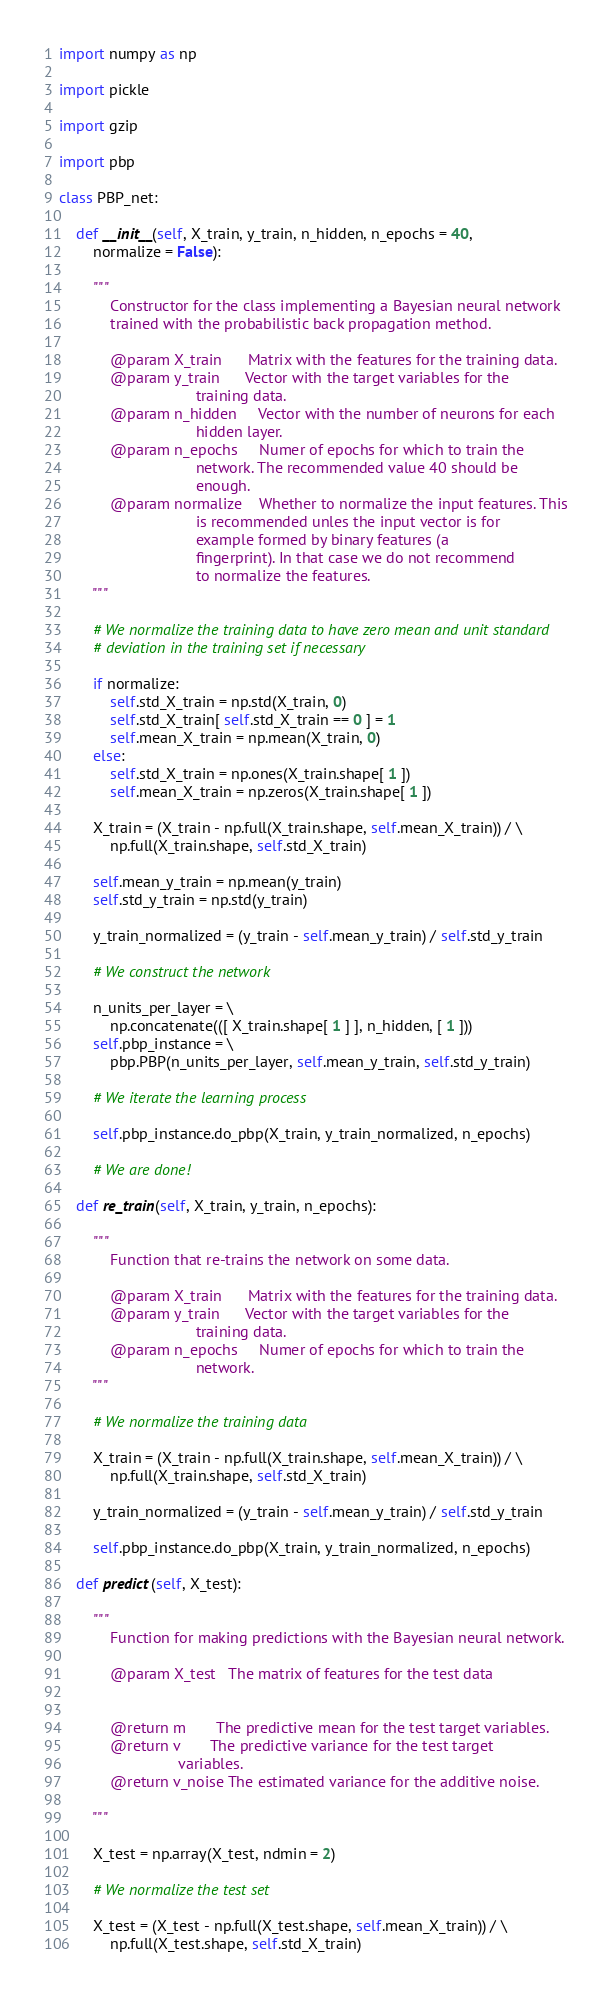<code> <loc_0><loc_0><loc_500><loc_500><_Python_>
import numpy as np

import pickle

import gzip

import pbp

class PBP_net:

    def __init__(self, X_train, y_train, n_hidden, n_epochs = 40,
        normalize = False):

        """
            Constructor for the class implementing a Bayesian neural network
            trained with the probabilistic back propagation method.

            @param X_train      Matrix with the features for the training data.
            @param y_train      Vector with the target variables for the
                                training data.
            @param n_hidden     Vector with the number of neurons for each
                                hidden layer.
            @param n_epochs     Numer of epochs for which to train the
                                network. The recommended value 40 should be
                                enough.
            @param normalize    Whether to normalize the input features. This
                                is recommended unles the input vector is for
                                example formed by binary features (a
                                fingerprint). In that case we do not recommend
                                to normalize the features.
        """

        # We normalize the training data to have zero mean and unit standard
        # deviation in the training set if necessary

        if normalize:
            self.std_X_train = np.std(X_train, 0)
            self.std_X_train[ self.std_X_train == 0 ] = 1
            self.mean_X_train = np.mean(X_train, 0)
        else:
            self.std_X_train = np.ones(X_train.shape[ 1 ])
            self.mean_X_train = np.zeros(X_train.shape[ 1 ])

        X_train = (X_train - np.full(X_train.shape, self.mean_X_train)) / \
            np.full(X_train.shape, self.std_X_train)

        self.mean_y_train = np.mean(y_train)
        self.std_y_train = np.std(y_train)

        y_train_normalized = (y_train - self.mean_y_train) / self.std_y_train

        # We construct the network

        n_units_per_layer = \
            np.concatenate(([ X_train.shape[ 1 ] ], n_hidden, [ 1 ]))
        self.pbp_instance = \
            pbp.PBP(n_units_per_layer, self.mean_y_train, self.std_y_train)

        # We iterate the learning process

        self.pbp_instance.do_pbp(X_train, y_train_normalized, n_epochs)

        # We are done!

    def re_train(self, X_train, y_train, n_epochs):

        """
            Function that re-trains the network on some data.

            @param X_train      Matrix with the features for the training data.
            @param y_train      Vector with the target variables for the
                                training data.
            @param n_epochs     Numer of epochs for which to train the
                                network. 
        """

        # We normalize the training data 

        X_train = (X_train - np.full(X_train.shape, self.mean_X_train)) / \
            np.full(X_train.shape, self.std_X_train)

        y_train_normalized = (y_train - self.mean_y_train) / self.std_y_train

        self.pbp_instance.do_pbp(X_train, y_train_normalized, n_epochs)

    def predict(self, X_test):

        """
            Function for making predictions with the Bayesian neural network.

            @param X_test   The matrix of features for the test data
            
    
            @return m       The predictive mean for the test target variables.
            @return v       The predictive variance for the test target
                            variables.
            @return v_noise The estimated variance for the additive noise.

        """

        X_test = np.array(X_test, ndmin = 2)

        # We normalize the test set

        X_test = (X_test - np.full(X_test.shape, self.mean_X_train)) / \
            np.full(X_test.shape, self.std_X_train)
</code> 